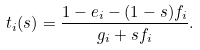Convert formula to latex. <formula><loc_0><loc_0><loc_500><loc_500>t _ { i } ( s ) = \frac { 1 - e _ { i } - ( 1 - s ) f _ { i } } { g _ { i } + s f _ { i } } .</formula> 